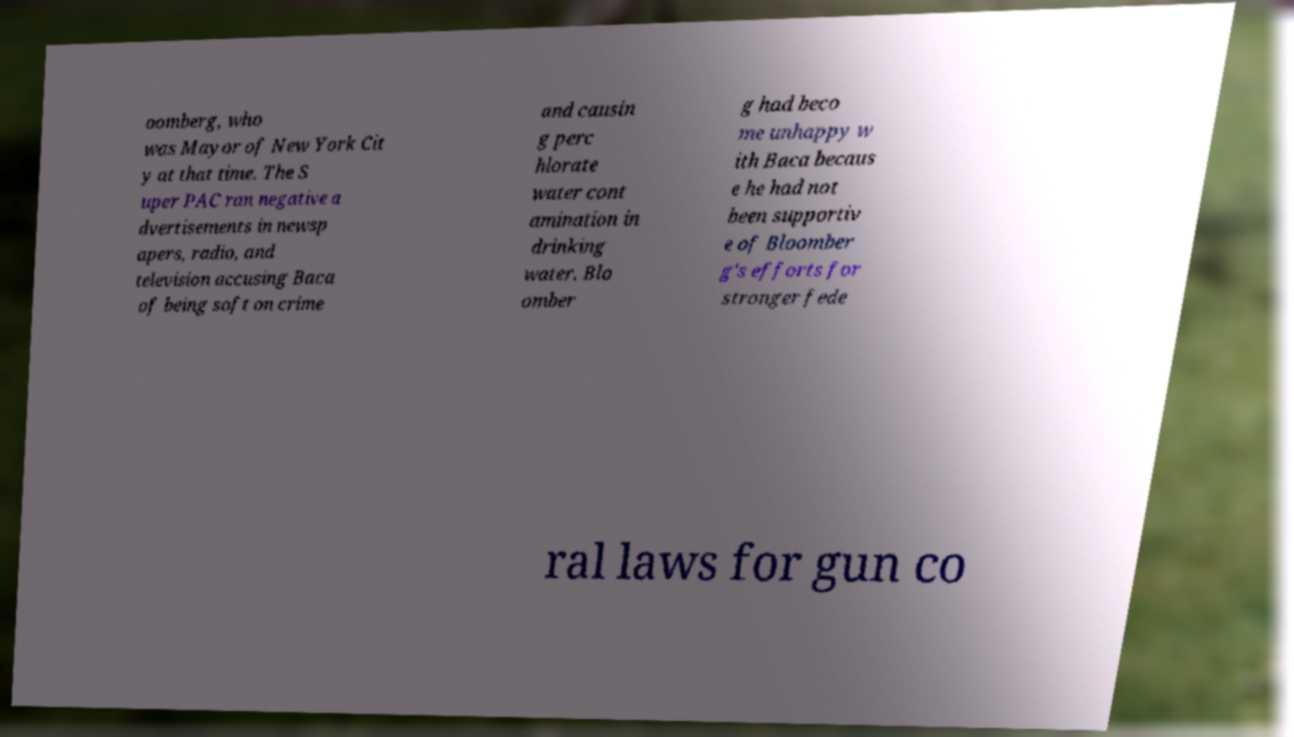Please identify and transcribe the text found in this image. oomberg, who was Mayor of New York Cit y at that time. The S uper PAC ran negative a dvertisements in newsp apers, radio, and television accusing Baca of being soft on crime and causin g perc hlorate water cont amination in drinking water. Blo omber g had beco me unhappy w ith Baca becaus e he had not been supportiv e of Bloomber g's efforts for stronger fede ral laws for gun co 